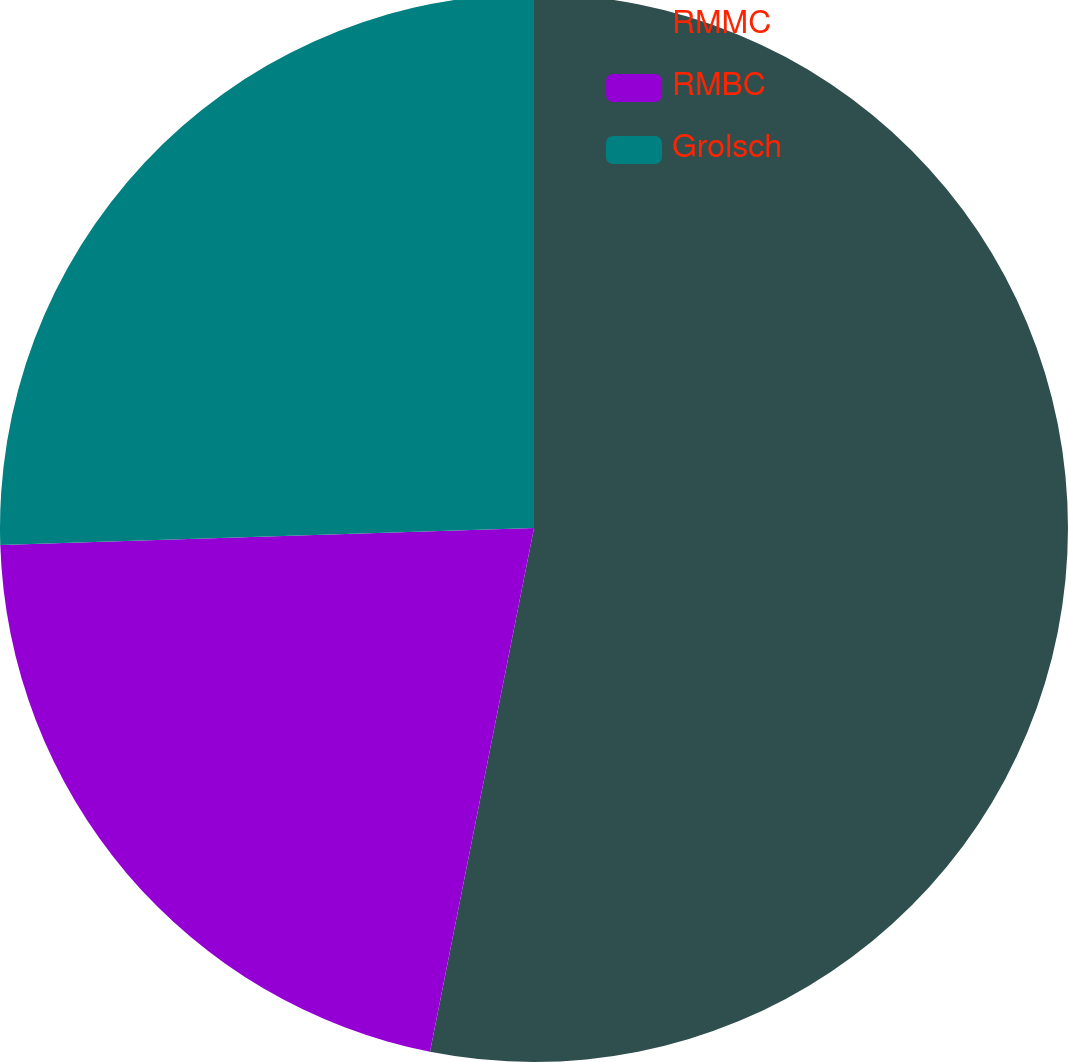Convert chart to OTSL. <chart><loc_0><loc_0><loc_500><loc_500><pie_chart><fcel>RMMC<fcel>RMBC<fcel>Grolsch<nl><fcel>53.12%<fcel>21.37%<fcel>25.51%<nl></chart> 